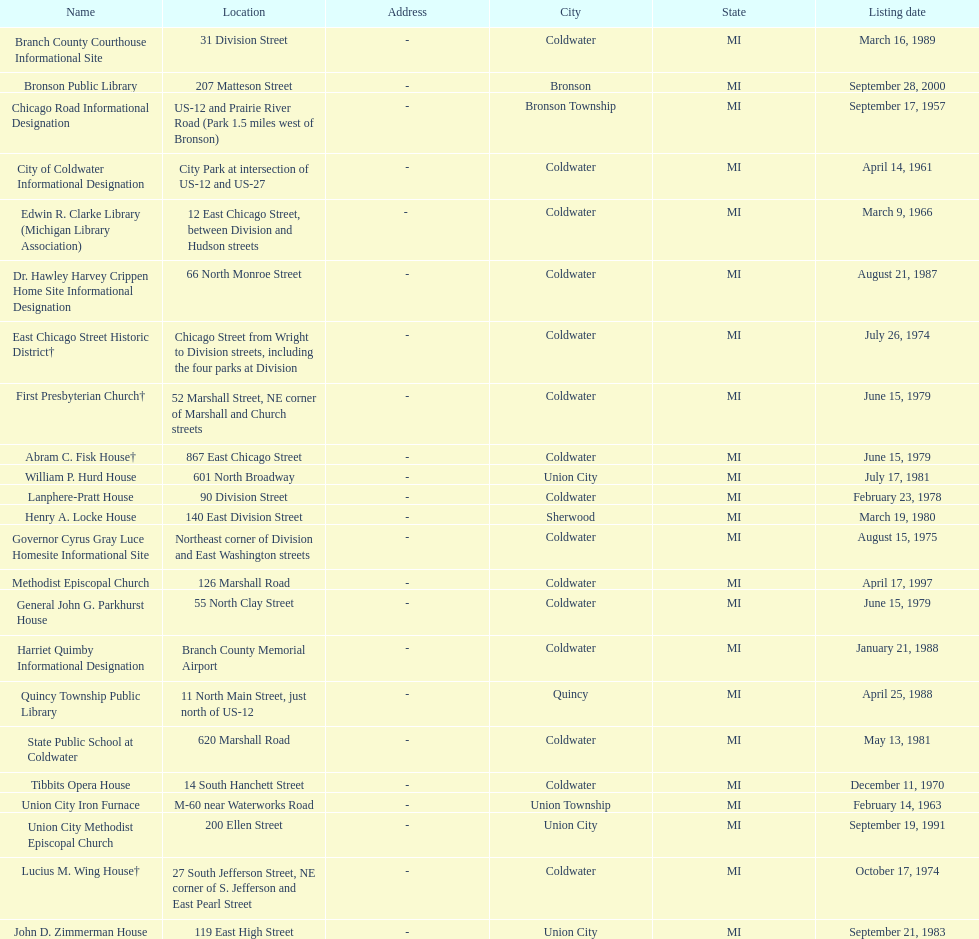Which city is home to the greatest number of historic landmarks? Coldwater. 